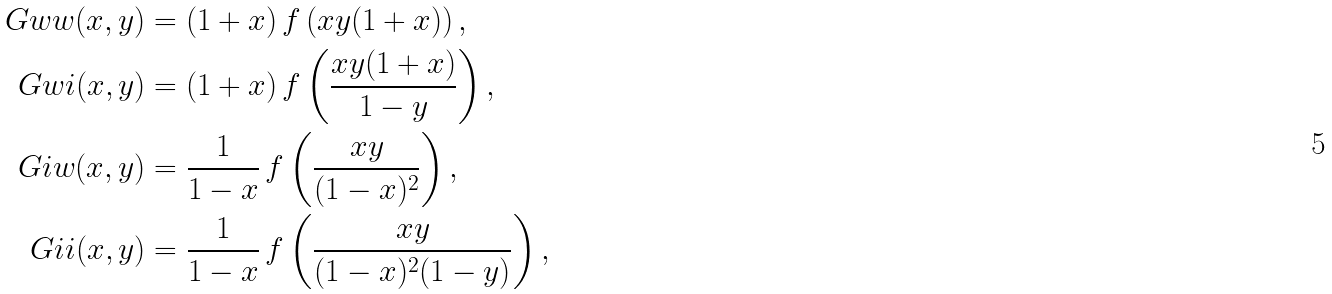<formula> <loc_0><loc_0><loc_500><loc_500>\ G w w ( x , y ) & = ( 1 + x ) \, f \left ( x y ( 1 + x ) \right ) , \\ \ G w i ( x , y ) & = ( 1 + x ) \, f \left ( \frac { x y ( 1 + x ) } { 1 - y } \right ) , \\ \ G i w ( x , y ) & = \frac { 1 } { 1 - x } \, f \left ( \frac { x y } { ( 1 - x ) ^ { 2 } } \right ) , \\ \ G i i ( x , y ) & = \frac { 1 } { 1 - x } \, f \left ( \frac { x y } { ( 1 - x ) ^ { 2 } ( 1 - y ) } \right ) ,</formula> 